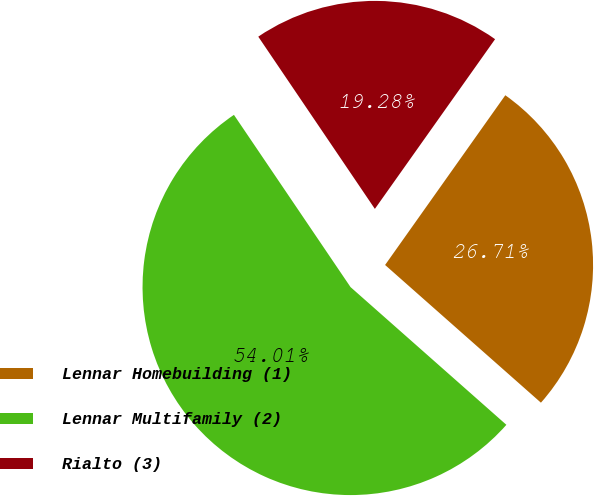<chart> <loc_0><loc_0><loc_500><loc_500><pie_chart><fcel>Lennar Homebuilding (1)<fcel>Lennar Multifamily (2)<fcel>Rialto (3)<nl><fcel>26.71%<fcel>54.01%<fcel>19.28%<nl></chart> 